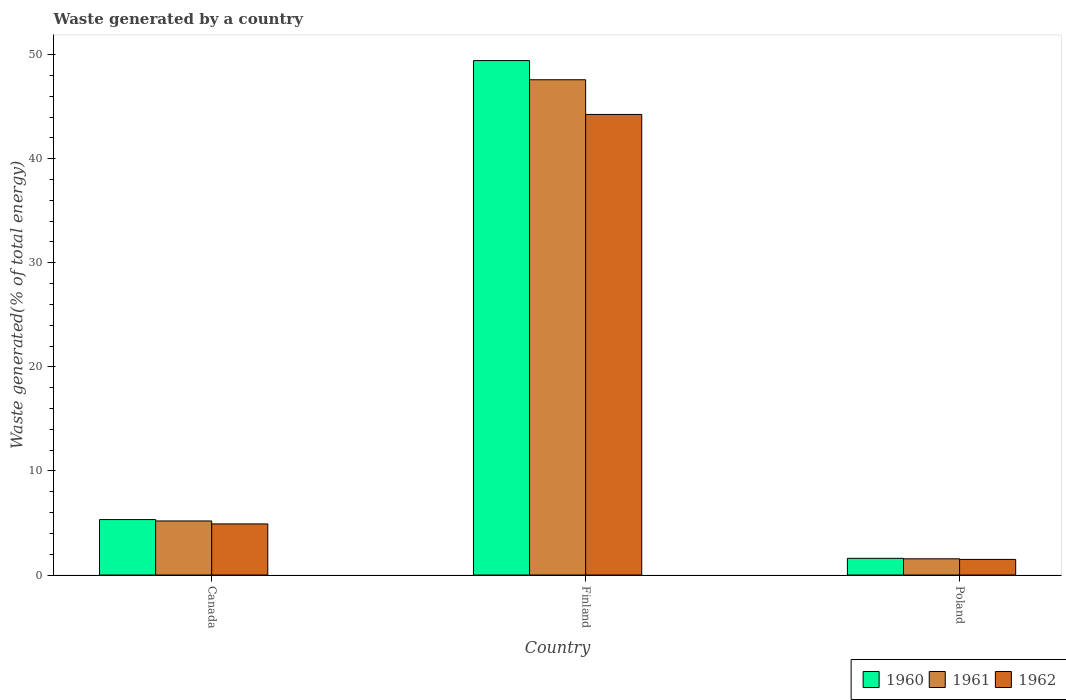How many different coloured bars are there?
Your response must be concise. 3. Are the number of bars on each tick of the X-axis equal?
Your answer should be compact. Yes. How many bars are there on the 3rd tick from the left?
Make the answer very short. 3. What is the label of the 3rd group of bars from the left?
Ensure brevity in your answer.  Poland. What is the total waste generated in 1960 in Poland?
Offer a very short reply. 1.6. Across all countries, what is the maximum total waste generated in 1960?
Give a very brief answer. 49.42. Across all countries, what is the minimum total waste generated in 1962?
Your response must be concise. 1.5. What is the total total waste generated in 1962 in the graph?
Your answer should be very brief. 50.66. What is the difference between the total waste generated in 1961 in Canada and that in Finland?
Offer a terse response. -42.39. What is the difference between the total waste generated in 1962 in Canada and the total waste generated in 1961 in Finland?
Provide a succinct answer. -42.67. What is the average total waste generated in 1962 per country?
Give a very brief answer. 16.89. What is the difference between the total waste generated of/in 1960 and total waste generated of/in 1961 in Canada?
Provide a short and direct response. 0.13. What is the ratio of the total waste generated in 1960 in Canada to that in Poland?
Offer a very short reply. 3.32. Is the total waste generated in 1962 in Canada less than that in Poland?
Offer a terse response. No. What is the difference between the highest and the second highest total waste generated in 1962?
Give a very brief answer. -42.75. What is the difference between the highest and the lowest total waste generated in 1961?
Your response must be concise. 46.02. Is the sum of the total waste generated in 1962 in Canada and Finland greater than the maximum total waste generated in 1960 across all countries?
Your answer should be very brief. No. Is it the case that in every country, the sum of the total waste generated in 1962 and total waste generated in 1960 is greater than the total waste generated in 1961?
Offer a very short reply. Yes. Are all the bars in the graph horizontal?
Your answer should be very brief. No. Are the values on the major ticks of Y-axis written in scientific E-notation?
Provide a short and direct response. No. How are the legend labels stacked?
Keep it short and to the point. Horizontal. What is the title of the graph?
Provide a succinct answer. Waste generated by a country. Does "1978" appear as one of the legend labels in the graph?
Give a very brief answer. No. What is the label or title of the Y-axis?
Offer a very short reply. Waste generated(% of total energy). What is the Waste generated(% of total energy) of 1960 in Canada?
Offer a very short reply. 5.33. What is the Waste generated(% of total energy) of 1961 in Canada?
Your answer should be compact. 5.19. What is the Waste generated(% of total energy) of 1962 in Canada?
Offer a terse response. 4.91. What is the Waste generated(% of total energy) of 1960 in Finland?
Offer a very short reply. 49.42. What is the Waste generated(% of total energy) in 1961 in Finland?
Keep it short and to the point. 47.58. What is the Waste generated(% of total energy) in 1962 in Finland?
Your response must be concise. 44.25. What is the Waste generated(% of total energy) of 1960 in Poland?
Provide a short and direct response. 1.6. What is the Waste generated(% of total energy) of 1961 in Poland?
Provide a succinct answer. 1.56. What is the Waste generated(% of total energy) in 1962 in Poland?
Provide a succinct answer. 1.5. Across all countries, what is the maximum Waste generated(% of total energy) in 1960?
Give a very brief answer. 49.42. Across all countries, what is the maximum Waste generated(% of total energy) in 1961?
Your response must be concise. 47.58. Across all countries, what is the maximum Waste generated(% of total energy) of 1962?
Provide a short and direct response. 44.25. Across all countries, what is the minimum Waste generated(% of total energy) in 1960?
Your response must be concise. 1.6. Across all countries, what is the minimum Waste generated(% of total energy) of 1961?
Provide a succinct answer. 1.56. Across all countries, what is the minimum Waste generated(% of total energy) in 1962?
Make the answer very short. 1.5. What is the total Waste generated(% of total energy) in 1960 in the graph?
Your response must be concise. 56.36. What is the total Waste generated(% of total energy) of 1961 in the graph?
Offer a terse response. 54.33. What is the total Waste generated(% of total energy) of 1962 in the graph?
Give a very brief answer. 50.66. What is the difference between the Waste generated(% of total energy) of 1960 in Canada and that in Finland?
Give a very brief answer. -44.1. What is the difference between the Waste generated(% of total energy) of 1961 in Canada and that in Finland?
Make the answer very short. -42.39. What is the difference between the Waste generated(% of total energy) of 1962 in Canada and that in Finland?
Your answer should be very brief. -39.34. What is the difference between the Waste generated(% of total energy) in 1960 in Canada and that in Poland?
Ensure brevity in your answer.  3.72. What is the difference between the Waste generated(% of total energy) of 1961 in Canada and that in Poland?
Your response must be concise. 3.64. What is the difference between the Waste generated(% of total energy) of 1962 in Canada and that in Poland?
Your response must be concise. 3.41. What is the difference between the Waste generated(% of total energy) of 1960 in Finland and that in Poland?
Ensure brevity in your answer.  47.82. What is the difference between the Waste generated(% of total energy) in 1961 in Finland and that in Poland?
Your response must be concise. 46.02. What is the difference between the Waste generated(% of total energy) of 1962 in Finland and that in Poland?
Give a very brief answer. 42.75. What is the difference between the Waste generated(% of total energy) of 1960 in Canada and the Waste generated(% of total energy) of 1961 in Finland?
Make the answer very short. -42.25. What is the difference between the Waste generated(% of total energy) in 1960 in Canada and the Waste generated(% of total energy) in 1962 in Finland?
Provide a succinct answer. -38.92. What is the difference between the Waste generated(% of total energy) in 1961 in Canada and the Waste generated(% of total energy) in 1962 in Finland?
Ensure brevity in your answer.  -39.06. What is the difference between the Waste generated(% of total energy) of 1960 in Canada and the Waste generated(% of total energy) of 1961 in Poland?
Offer a very short reply. 3.77. What is the difference between the Waste generated(% of total energy) in 1960 in Canada and the Waste generated(% of total energy) in 1962 in Poland?
Provide a succinct answer. 3.83. What is the difference between the Waste generated(% of total energy) in 1961 in Canada and the Waste generated(% of total energy) in 1962 in Poland?
Keep it short and to the point. 3.7. What is the difference between the Waste generated(% of total energy) in 1960 in Finland and the Waste generated(% of total energy) in 1961 in Poland?
Keep it short and to the point. 47.86. What is the difference between the Waste generated(% of total energy) of 1960 in Finland and the Waste generated(% of total energy) of 1962 in Poland?
Your response must be concise. 47.92. What is the difference between the Waste generated(% of total energy) in 1961 in Finland and the Waste generated(% of total energy) in 1962 in Poland?
Offer a very short reply. 46.08. What is the average Waste generated(% of total energy) of 1960 per country?
Offer a terse response. 18.79. What is the average Waste generated(% of total energy) in 1961 per country?
Your answer should be very brief. 18.11. What is the average Waste generated(% of total energy) in 1962 per country?
Ensure brevity in your answer.  16.89. What is the difference between the Waste generated(% of total energy) in 1960 and Waste generated(% of total energy) in 1961 in Canada?
Offer a terse response. 0.13. What is the difference between the Waste generated(% of total energy) in 1960 and Waste generated(% of total energy) in 1962 in Canada?
Make the answer very short. 0.42. What is the difference between the Waste generated(% of total energy) of 1961 and Waste generated(% of total energy) of 1962 in Canada?
Your response must be concise. 0.28. What is the difference between the Waste generated(% of total energy) of 1960 and Waste generated(% of total energy) of 1961 in Finland?
Provide a succinct answer. 1.84. What is the difference between the Waste generated(% of total energy) in 1960 and Waste generated(% of total energy) in 1962 in Finland?
Your response must be concise. 5.17. What is the difference between the Waste generated(% of total energy) in 1961 and Waste generated(% of total energy) in 1962 in Finland?
Offer a very short reply. 3.33. What is the difference between the Waste generated(% of total energy) of 1960 and Waste generated(% of total energy) of 1961 in Poland?
Your answer should be compact. 0.05. What is the difference between the Waste generated(% of total energy) in 1960 and Waste generated(% of total energy) in 1962 in Poland?
Your answer should be compact. 0.11. What is the difference between the Waste generated(% of total energy) of 1961 and Waste generated(% of total energy) of 1962 in Poland?
Your response must be concise. 0.06. What is the ratio of the Waste generated(% of total energy) in 1960 in Canada to that in Finland?
Give a very brief answer. 0.11. What is the ratio of the Waste generated(% of total energy) of 1961 in Canada to that in Finland?
Offer a very short reply. 0.11. What is the ratio of the Waste generated(% of total energy) of 1962 in Canada to that in Finland?
Keep it short and to the point. 0.11. What is the ratio of the Waste generated(% of total energy) in 1960 in Canada to that in Poland?
Offer a very short reply. 3.32. What is the ratio of the Waste generated(% of total energy) in 1961 in Canada to that in Poland?
Give a very brief answer. 3.33. What is the ratio of the Waste generated(% of total energy) in 1962 in Canada to that in Poland?
Your answer should be very brief. 3.28. What is the ratio of the Waste generated(% of total energy) in 1960 in Finland to that in Poland?
Provide a succinct answer. 30.8. What is the ratio of the Waste generated(% of total energy) of 1961 in Finland to that in Poland?
Make the answer very short. 30.53. What is the ratio of the Waste generated(% of total energy) of 1962 in Finland to that in Poland?
Your answer should be very brief. 29.52. What is the difference between the highest and the second highest Waste generated(% of total energy) of 1960?
Offer a very short reply. 44.1. What is the difference between the highest and the second highest Waste generated(% of total energy) in 1961?
Your answer should be compact. 42.39. What is the difference between the highest and the second highest Waste generated(% of total energy) in 1962?
Your answer should be compact. 39.34. What is the difference between the highest and the lowest Waste generated(% of total energy) of 1960?
Your answer should be compact. 47.82. What is the difference between the highest and the lowest Waste generated(% of total energy) of 1961?
Your answer should be compact. 46.02. What is the difference between the highest and the lowest Waste generated(% of total energy) in 1962?
Your answer should be compact. 42.75. 